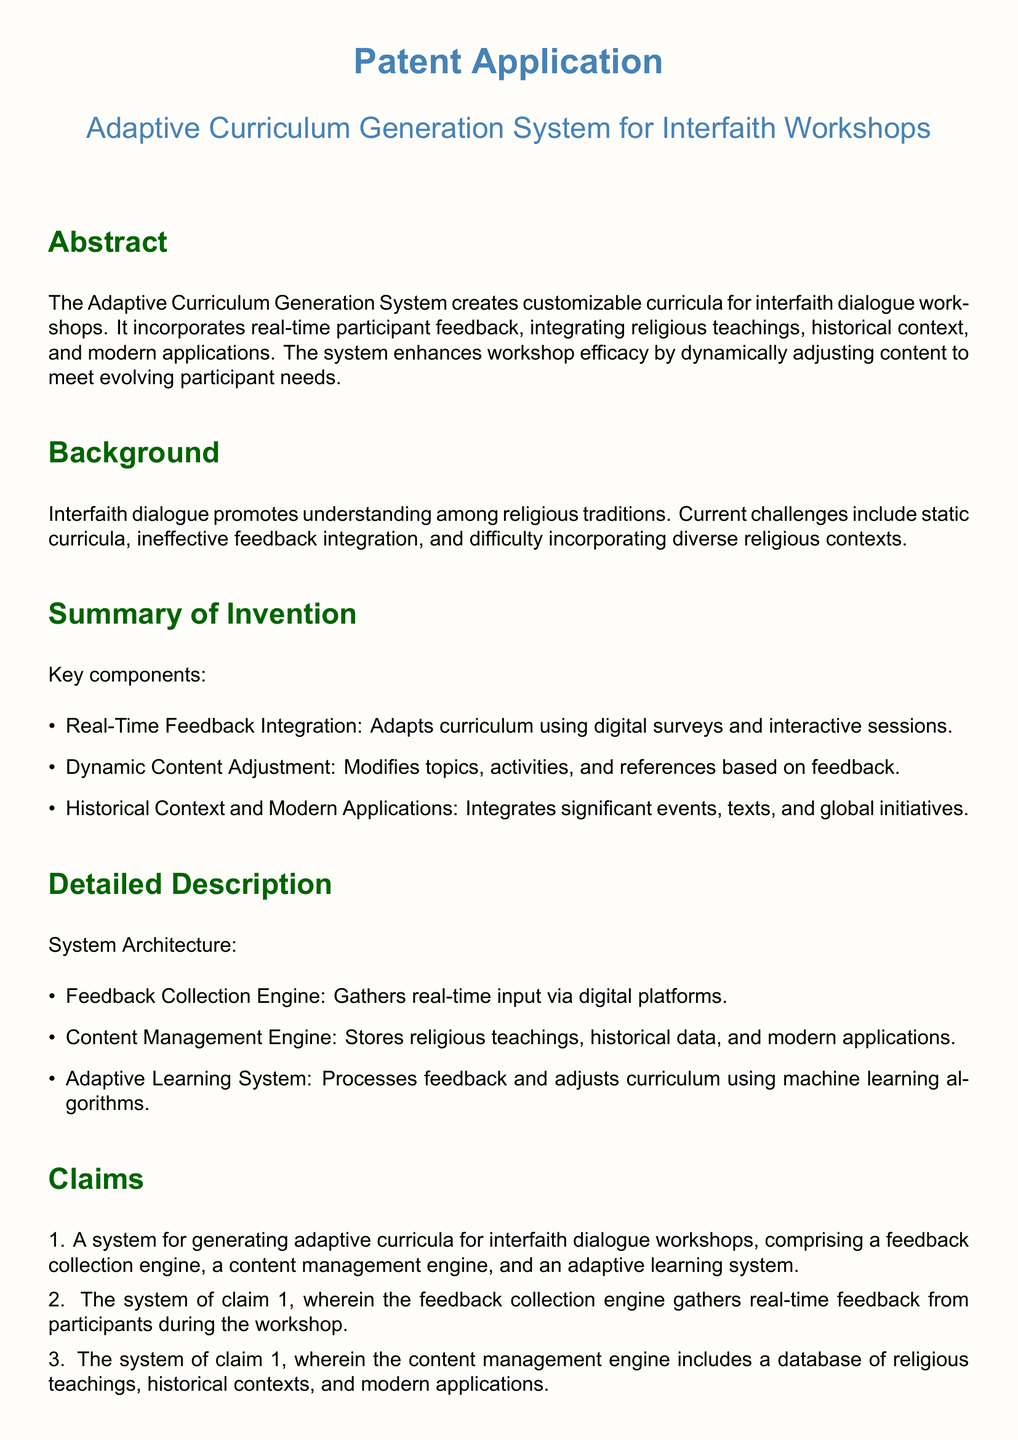What is the title of the patent application? The title of the patent application is explicitly stated in the document.
Answer: Adaptive Curriculum Generation System for Interfaith Workshops What are the key components listed in the summary of the invention? The key components are detailed in the summary section of the document.
Answer: Real-Time Feedback Integration, Dynamic Content Adjustment, Historical Context and Modern Applications What does the feedback collection engine do? The feedback collection engine's function is mentioned in the detailed description.
Answer: Gathers real-time input via digital platforms How does the adaptive learning system adjust the curriculum? The method used by the adaptive learning system to modify the curriculum is described in the document.
Answer: Processes feedback and adjusts curriculum using machine learning algorithms What is the primary benefit of the Adaptive Curriculum Generation System? The primary benefit is stated in the conclusion of the document.
Answer: Enhances effectiveness and relevance of interfaith dialogues What type of feedback does the system collect during workshops? The document specifies the nature of feedback collected.
Answer: Real-time feedback from participants What is one example use case provided in the document? An example use case is detailed to illustrate the system's application.
Answer: Curriculum adjusts to include historical context on interfaith cooperation in the Middle Ages How many claims are listed in the patent application? The number of claims is counted from the claims section in the document.
Answer: Four claims 